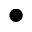Convert formula to latex. <formula><loc_0><loc_0><loc_500><loc_500>\bullet</formula> 